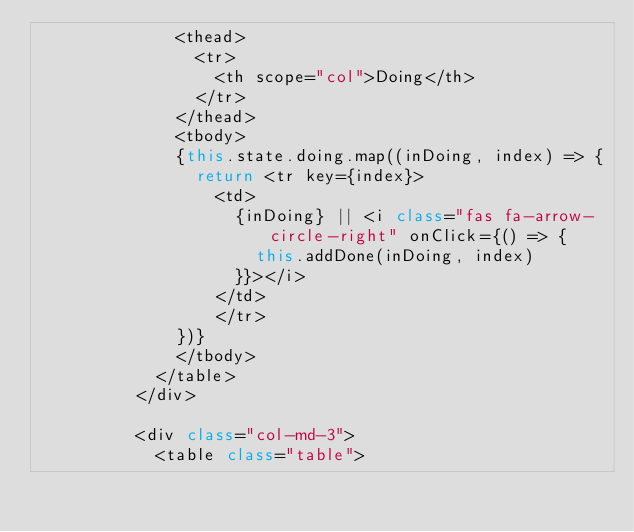<code> <loc_0><loc_0><loc_500><loc_500><_JavaScript_>              <thead>
                <tr>
                  <th scope="col">Doing</th>
                </tr>
              </thead>
              <tbody>
              {this.state.doing.map((inDoing, index) => {
                return <tr key={index}>
                  <td>
                    {inDoing} || <i class="fas fa-arrow-circle-right" onClick={() => {
                      this.addDone(inDoing, index)
                    }}></i>
                  </td>
                  </tr>
              })}
              </tbody>
            </table>
          </div>

          <div class="col-md-3">
            <table class="table"></code> 